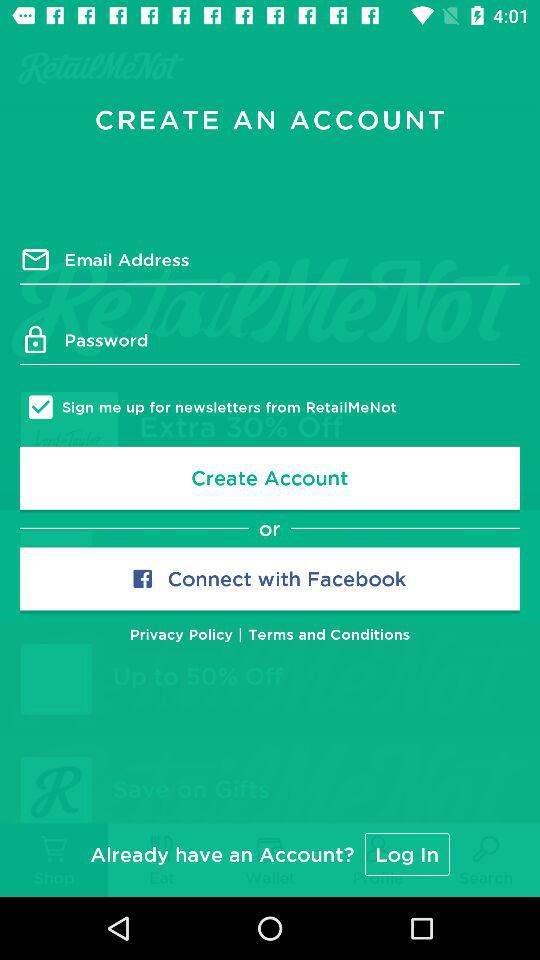What are the requirements for creating an account? The requirements for creating an account are email address and password. 